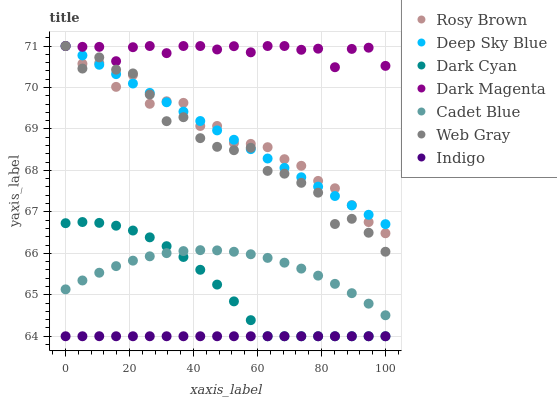Does Indigo have the minimum area under the curve?
Answer yes or no. Yes. Does Dark Magenta have the maximum area under the curve?
Answer yes or no. Yes. Does Dark Magenta have the minimum area under the curve?
Answer yes or no. No. Does Indigo have the maximum area under the curve?
Answer yes or no. No. Is Deep Sky Blue the smoothest?
Answer yes or no. Yes. Is Web Gray the roughest?
Answer yes or no. Yes. Is Indigo the smoothest?
Answer yes or no. No. Is Indigo the roughest?
Answer yes or no. No. Does Indigo have the lowest value?
Answer yes or no. Yes. Does Dark Magenta have the lowest value?
Answer yes or no. No. Does Deep Sky Blue have the highest value?
Answer yes or no. Yes. Does Indigo have the highest value?
Answer yes or no. No. Is Dark Cyan less than Deep Sky Blue?
Answer yes or no. Yes. Is Dark Magenta greater than Indigo?
Answer yes or no. Yes. Does Rosy Brown intersect Web Gray?
Answer yes or no. Yes. Is Rosy Brown less than Web Gray?
Answer yes or no. No. Is Rosy Brown greater than Web Gray?
Answer yes or no. No. Does Dark Cyan intersect Deep Sky Blue?
Answer yes or no. No. 